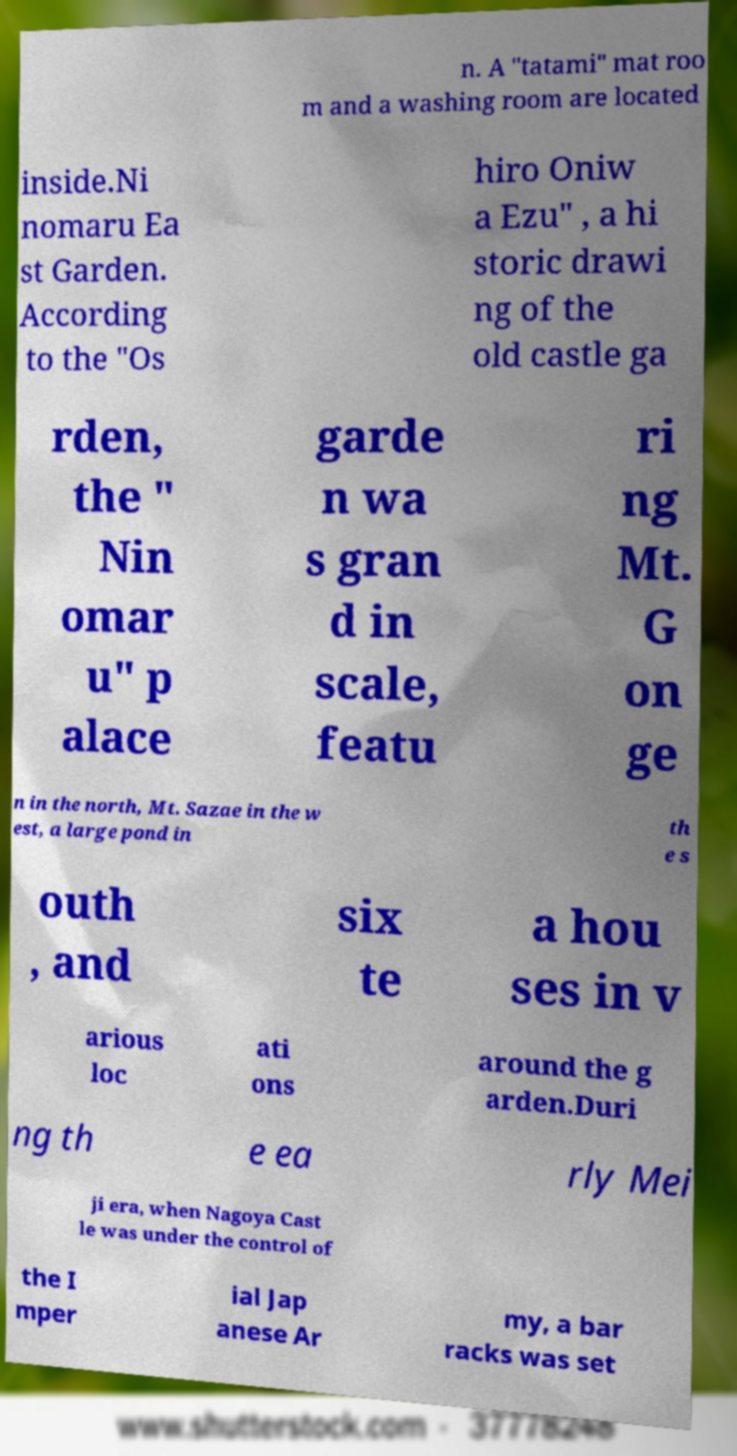Please read and relay the text visible in this image. What does it say? n. A "tatami" mat roo m and a washing room are located inside.Ni nomaru Ea st Garden. According to the "Os hiro Oniw a Ezu" , a hi storic drawi ng of the old castle ga rden, the " Nin omar u" p alace garde n wa s gran d in scale, featu ri ng Mt. G on ge n in the north, Mt. Sazae in the w est, a large pond in th e s outh , and six te a hou ses in v arious loc ati ons around the g arden.Duri ng th e ea rly Mei ji era, when Nagoya Cast le was under the control of the I mper ial Jap anese Ar my, a bar racks was set 